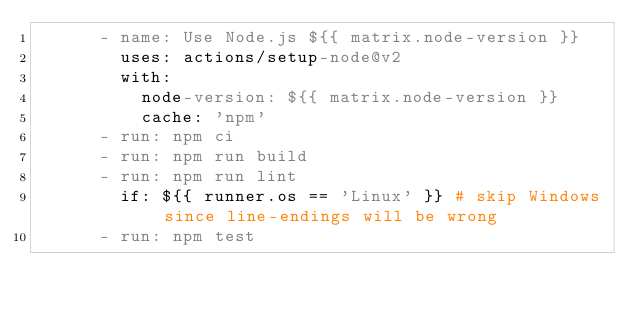Convert code to text. <code><loc_0><loc_0><loc_500><loc_500><_YAML_>      - name: Use Node.js ${{ matrix.node-version }}
        uses: actions/setup-node@v2
        with:
          node-version: ${{ matrix.node-version }}
          cache: 'npm'
      - run: npm ci
      - run: npm run build
      - run: npm run lint
        if: ${{ runner.os == 'Linux' }} # skip Windows since line-endings will be wrong
      - run: npm test
</code> 